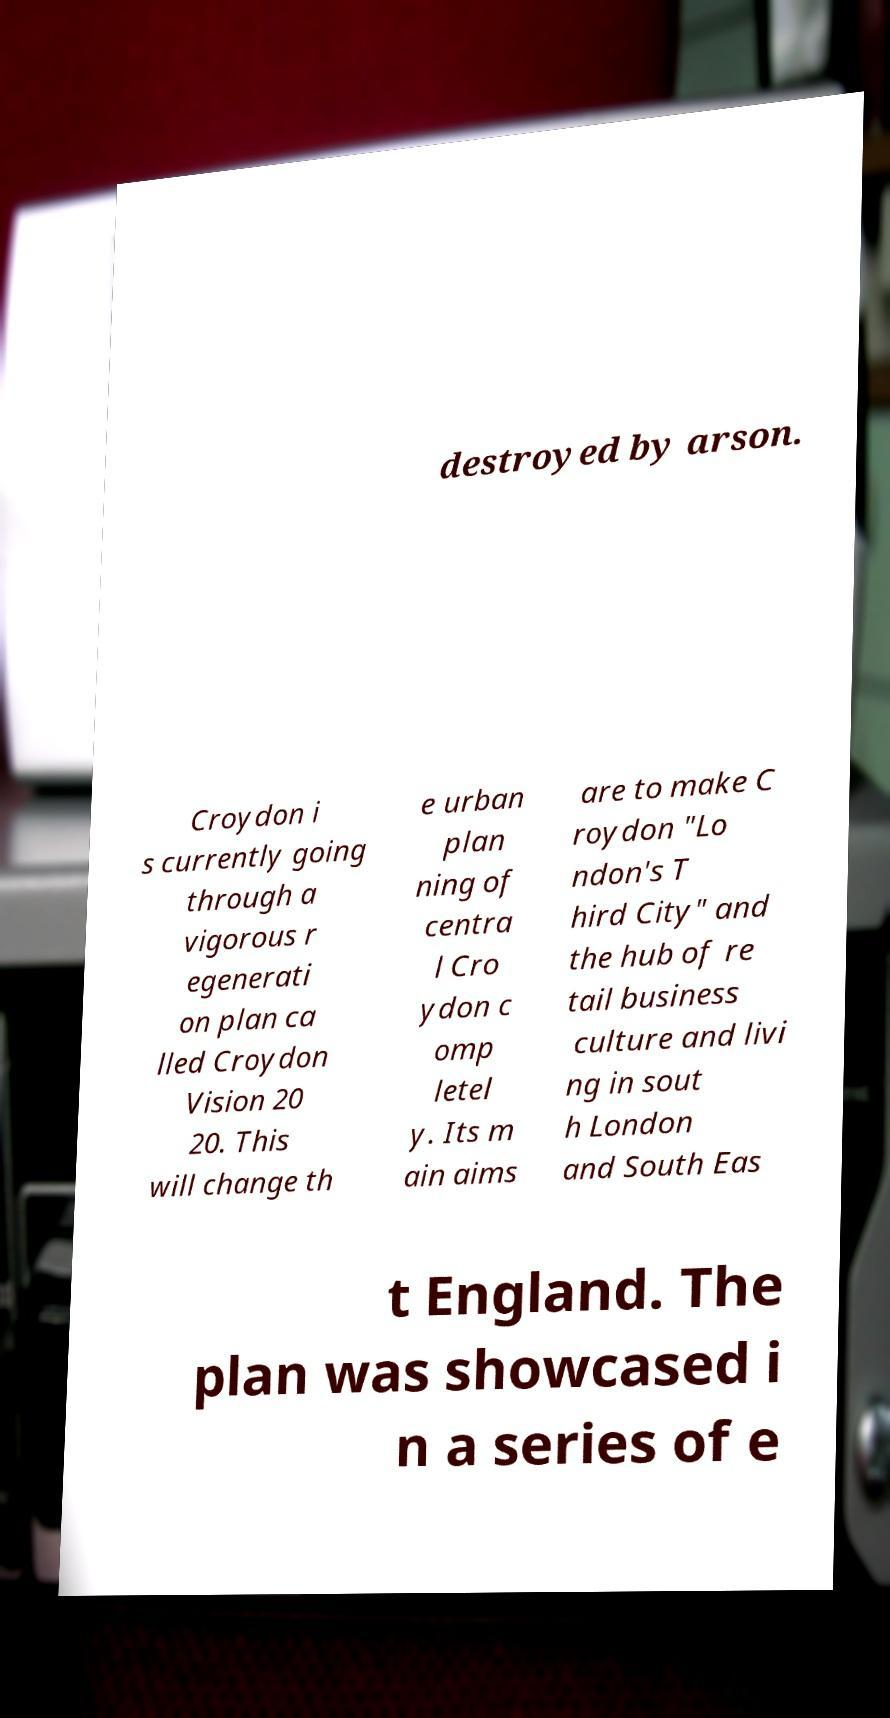Could you assist in decoding the text presented in this image and type it out clearly? destroyed by arson. Croydon i s currently going through a vigorous r egenerati on plan ca lled Croydon Vision 20 20. This will change th e urban plan ning of centra l Cro ydon c omp letel y. Its m ain aims are to make C roydon "Lo ndon's T hird City" and the hub of re tail business culture and livi ng in sout h London and South Eas t England. The plan was showcased i n a series of e 